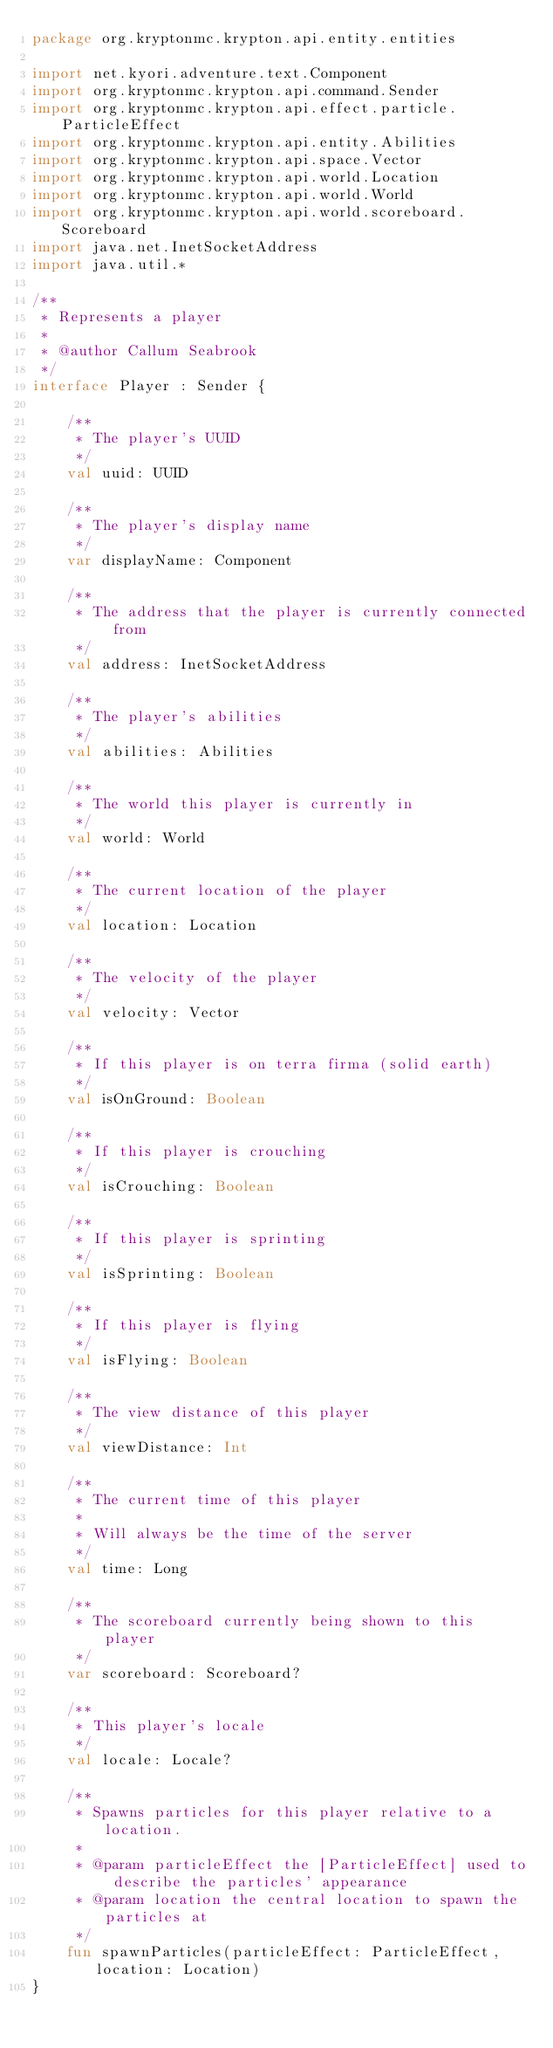Convert code to text. <code><loc_0><loc_0><loc_500><loc_500><_Kotlin_>package org.kryptonmc.krypton.api.entity.entities

import net.kyori.adventure.text.Component
import org.kryptonmc.krypton.api.command.Sender
import org.kryptonmc.krypton.api.effect.particle.ParticleEffect
import org.kryptonmc.krypton.api.entity.Abilities
import org.kryptonmc.krypton.api.space.Vector
import org.kryptonmc.krypton.api.world.Location
import org.kryptonmc.krypton.api.world.World
import org.kryptonmc.krypton.api.world.scoreboard.Scoreboard
import java.net.InetSocketAddress
import java.util.*

/**
 * Represents a player
 *
 * @author Callum Seabrook
 */
interface Player : Sender {

    /**
     * The player's UUID
     */
    val uuid: UUID

    /**
     * The player's display name
     */
    var displayName: Component

    /**
     * The address that the player is currently connected from
     */
    val address: InetSocketAddress

    /**
     * The player's abilities
     */
    val abilities: Abilities

    /**
     * The world this player is currently in
     */
    val world: World

    /**
     * The current location of the player
     */
    val location: Location

    /**
     * The velocity of the player
     */
    val velocity: Vector

    /**
     * If this player is on terra firma (solid earth)
     */
    val isOnGround: Boolean

    /**
     * If this player is crouching
     */
    val isCrouching: Boolean

    /**
     * If this player is sprinting
     */
    val isSprinting: Boolean

    /**
     * If this player is flying
     */
    val isFlying: Boolean

    /**
     * The view distance of this player
     */
    val viewDistance: Int

    /**
     * The current time of this player
     *
     * Will always be the time of the server
     */
    val time: Long

    /**
     * The scoreboard currently being shown to this player
     */
    var scoreboard: Scoreboard?

    /**
     * This player's locale
     */
    val locale: Locale?

    /**
     * Spawns particles for this player relative to a location.
     *
     * @param particleEffect the [ParticleEffect] used to describe the particles' appearance
     * @param location the central location to spawn the particles at
     */
    fun spawnParticles(particleEffect: ParticleEffect, location: Location)
}</code> 